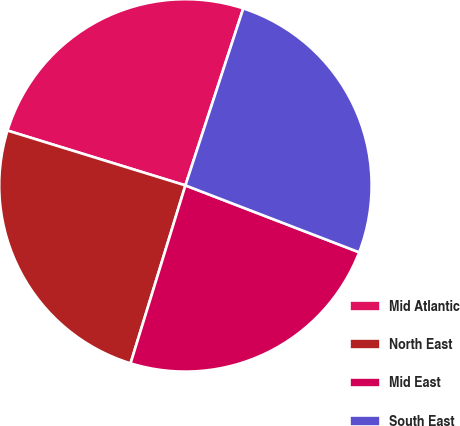Convert chart to OTSL. <chart><loc_0><loc_0><loc_500><loc_500><pie_chart><fcel>Mid Atlantic<fcel>North East<fcel>Mid East<fcel>South East<nl><fcel>25.27%<fcel>25.0%<fcel>23.91%<fcel>25.82%<nl></chart> 